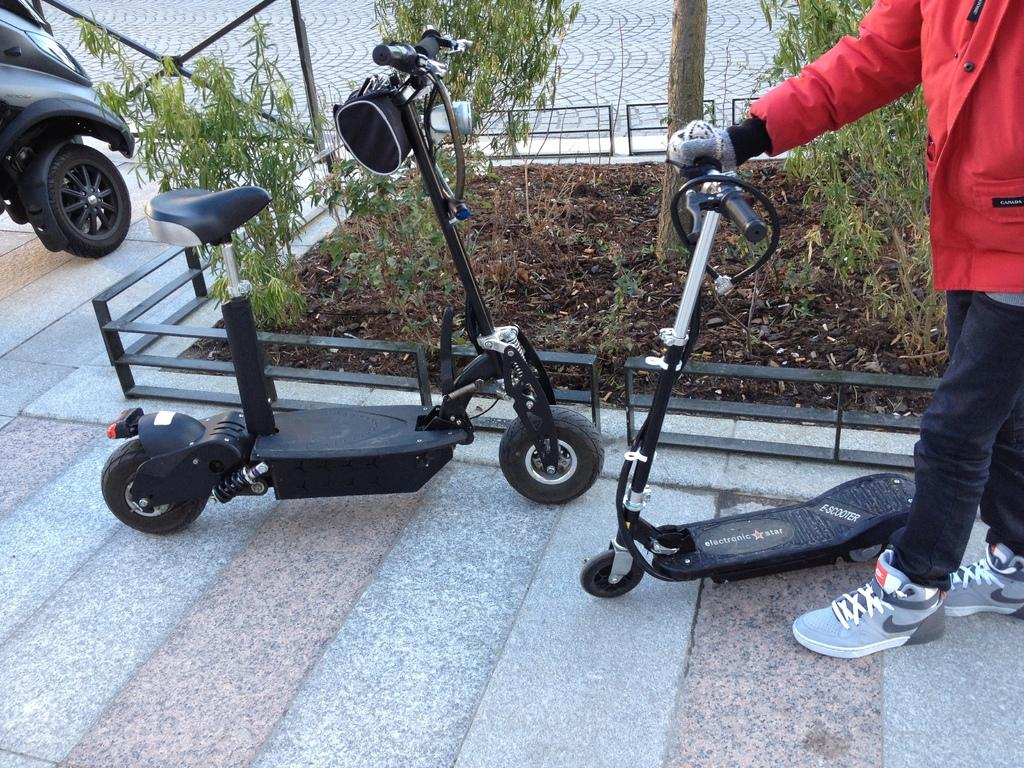What type of vehicles are present in the image? There are two scooters and a bike in the image. Can you describe the person in the image? There is a person in the image, but their specific appearance or actions are not mentioned in the facts. What else can be seen in the image besides the vehicles and person? There are plants in the image. What type of prose can be heard being read by the person in the image? There is no indication in the image that someone is reading prose, so it cannot be determined from the picture. 